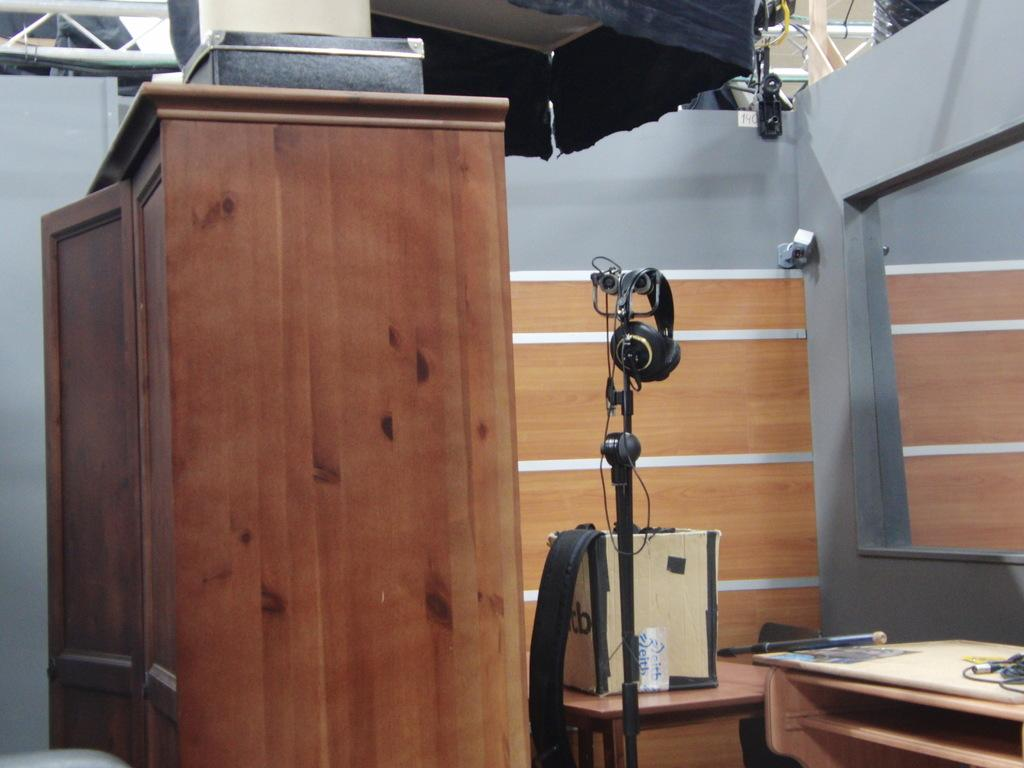What object is placed on a cupboard in the image? There is a box on a cupboard in the image. What type of furniture is present in the image? There is a stand and tables in the image. What is the purpose of the stick in the image? The purpose of the stick is not clear from the image, but it is present. What device is visible in the image? There is a headset in the image. What can be seen in the background of the image? There is a wall visible in the background of the image. What type of island is visible in the image? There is no island present in the image. What texture can be seen on the wall in the image? The texture of the wall is not visible in the image. 